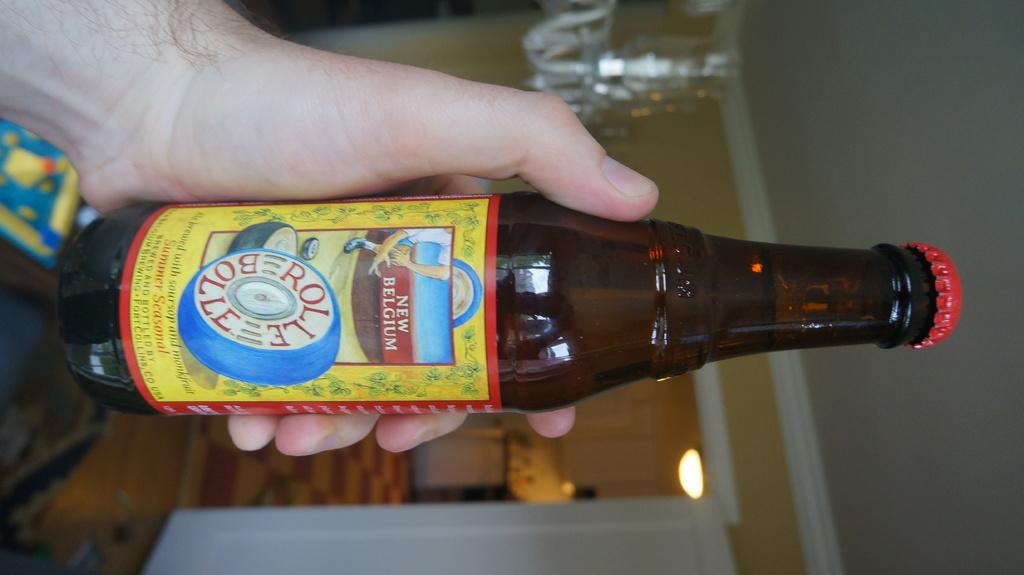What is the person in the image holding? The person is holding a bottle in the image. What is unique about the bottle? There is a sticker attached to the bottle. What can be seen in the background of the image? There is a door, a light, and a wall visible in the background of the image. What type of trees can be seen through the door in the image? There are no trees visible in the image, and the door is not open to reveal any scenery beyond it. 